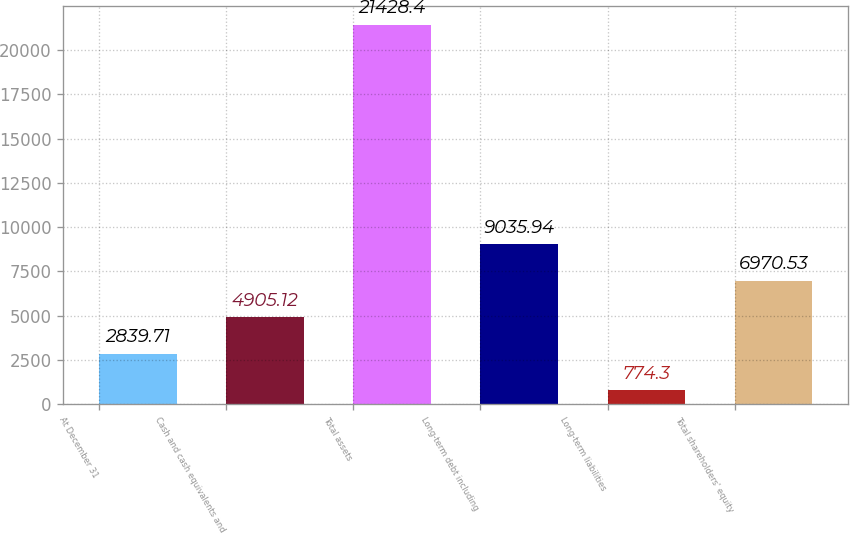Convert chart to OTSL. <chart><loc_0><loc_0><loc_500><loc_500><bar_chart><fcel>At December 31<fcel>Cash and cash equivalents and<fcel>Total assets<fcel>Long-term debt including<fcel>Long-term liabilities<fcel>Total shareholders' equity<nl><fcel>2839.71<fcel>4905.12<fcel>21428.4<fcel>9035.94<fcel>774.3<fcel>6970.53<nl></chart> 